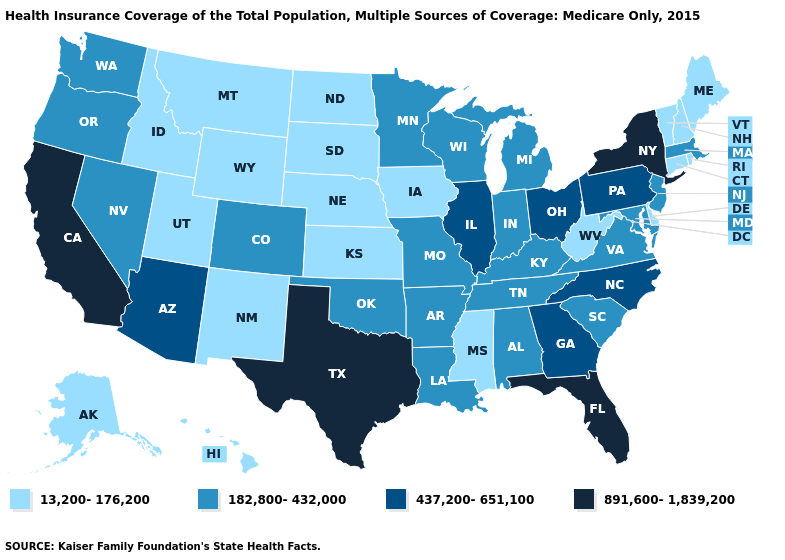Which states have the highest value in the USA?
Be succinct. California, Florida, New York, Texas. Does the map have missing data?
Give a very brief answer. No. Name the states that have a value in the range 437,200-651,100?
Give a very brief answer. Arizona, Georgia, Illinois, North Carolina, Ohio, Pennsylvania. What is the value of Florida?
Concise answer only. 891,600-1,839,200. What is the lowest value in the USA?
Concise answer only. 13,200-176,200. Does North Dakota have a lower value than New Jersey?
Short answer required. Yes. What is the value of New Jersey?
Concise answer only. 182,800-432,000. What is the lowest value in states that border Montana?
Short answer required. 13,200-176,200. Does the first symbol in the legend represent the smallest category?
Quick response, please. Yes. What is the value of South Dakota?
Write a very short answer. 13,200-176,200. What is the highest value in the Northeast ?
Answer briefly. 891,600-1,839,200. What is the highest value in states that border Maryland?
Quick response, please. 437,200-651,100. Name the states that have a value in the range 891,600-1,839,200?
Quick response, please. California, Florida, New York, Texas. What is the highest value in the West ?
Concise answer only. 891,600-1,839,200. Name the states that have a value in the range 437,200-651,100?
Be succinct. Arizona, Georgia, Illinois, North Carolina, Ohio, Pennsylvania. 